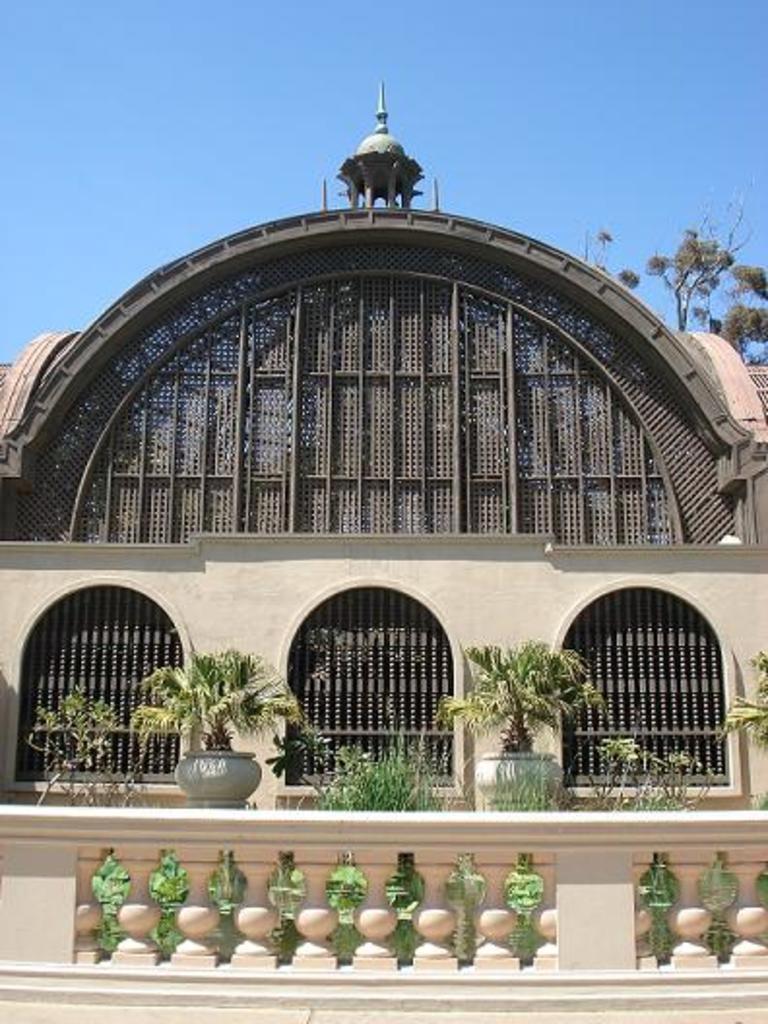In one or two sentences, can you explain what this image depicts? In this image I can see a building. Here I can see flower pots and a tree. In the background I can see the sky. 